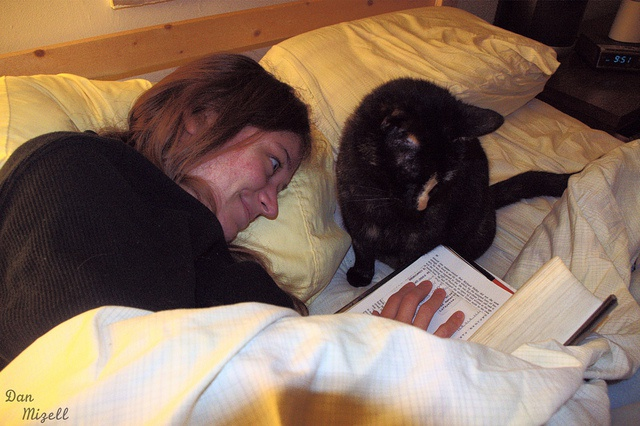Describe the objects in this image and their specific colors. I can see people in olive, black, lightgray, khaki, and maroon tones, bed in olive, tan, and gray tones, cat in olive, black, gray, and brown tones, book in olive, tan, darkgray, and black tones, and clock in olive, black, navy, and blue tones in this image. 